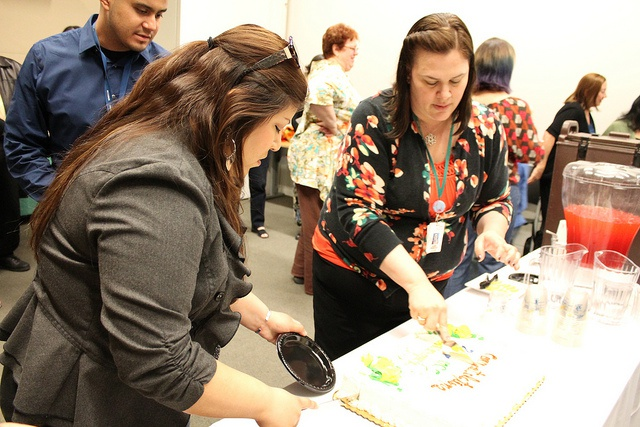Describe the objects in this image and their specific colors. I can see people in tan, black, gray, and maroon tones, people in tan, black, and beige tones, dining table in tan, white, and khaki tones, people in tan, black, and gray tones, and cake in tan, white, khaki, and orange tones in this image. 